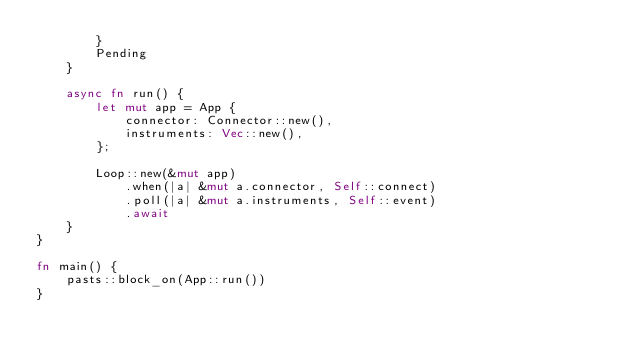<code> <loc_0><loc_0><loc_500><loc_500><_Rust_>        }
        Pending
    }

    async fn run() {
        let mut app = App {
            connector: Connector::new(),
            instruments: Vec::new(),
        };

        Loop::new(&mut app)
            .when(|a| &mut a.connector, Self::connect)
            .poll(|a| &mut a.instruments, Self::event)
            .await
    }
}

fn main() {
    pasts::block_on(App::run())
}
</code> 